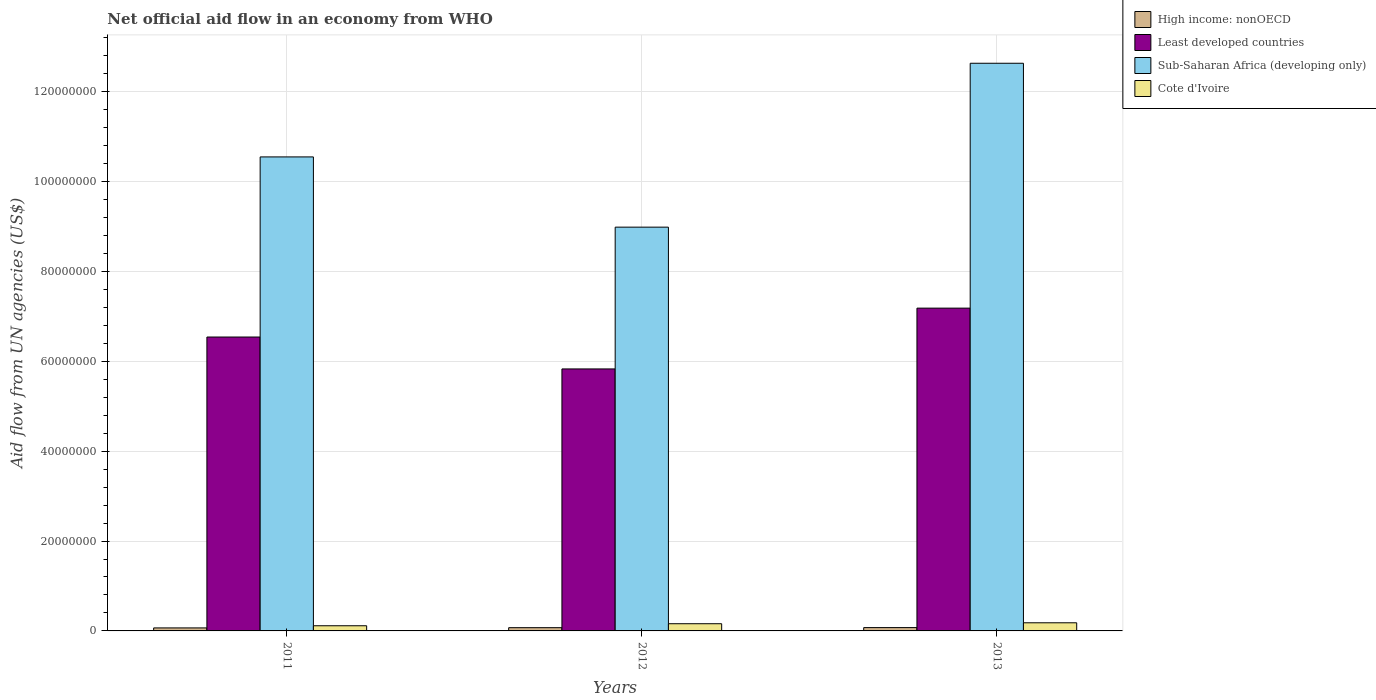How many groups of bars are there?
Offer a very short reply. 3. How many bars are there on the 2nd tick from the left?
Your response must be concise. 4. What is the label of the 1st group of bars from the left?
Provide a succinct answer. 2011. In how many cases, is the number of bars for a given year not equal to the number of legend labels?
Provide a short and direct response. 0. What is the net official aid flow in Sub-Saharan Africa (developing only) in 2011?
Your answer should be compact. 1.05e+08. Across all years, what is the maximum net official aid flow in Cote d'Ivoire?
Ensure brevity in your answer.  1.81e+06. Across all years, what is the minimum net official aid flow in High income: nonOECD?
Your answer should be compact. 6.70e+05. In which year was the net official aid flow in High income: nonOECD maximum?
Make the answer very short. 2013. What is the total net official aid flow in High income: nonOECD in the graph?
Make the answer very short. 2.13e+06. What is the difference between the net official aid flow in Sub-Saharan Africa (developing only) in 2011 and that in 2012?
Keep it short and to the point. 1.56e+07. What is the difference between the net official aid flow in Sub-Saharan Africa (developing only) in 2012 and the net official aid flow in Cote d'Ivoire in 2013?
Offer a terse response. 8.80e+07. What is the average net official aid flow in Least developed countries per year?
Offer a terse response. 6.52e+07. In the year 2011, what is the difference between the net official aid flow in Least developed countries and net official aid flow in Sub-Saharan Africa (developing only)?
Your response must be concise. -4.01e+07. In how many years, is the net official aid flow in Cote d'Ivoire greater than 76000000 US$?
Provide a short and direct response. 0. What is the ratio of the net official aid flow in High income: nonOECD in 2012 to that in 2013?
Give a very brief answer. 0.97. Is the difference between the net official aid flow in Least developed countries in 2012 and 2013 greater than the difference between the net official aid flow in Sub-Saharan Africa (developing only) in 2012 and 2013?
Offer a terse response. Yes. What is the difference between the highest and the second highest net official aid flow in Least developed countries?
Offer a very short reply. 6.43e+06. What is the difference between the highest and the lowest net official aid flow in High income: nonOECD?
Keep it short and to the point. 7.00e+04. In how many years, is the net official aid flow in Sub-Saharan Africa (developing only) greater than the average net official aid flow in Sub-Saharan Africa (developing only) taken over all years?
Your answer should be very brief. 1. What does the 3rd bar from the left in 2011 represents?
Provide a short and direct response. Sub-Saharan Africa (developing only). What does the 3rd bar from the right in 2011 represents?
Give a very brief answer. Least developed countries. Is it the case that in every year, the sum of the net official aid flow in Cote d'Ivoire and net official aid flow in Sub-Saharan Africa (developing only) is greater than the net official aid flow in Least developed countries?
Provide a short and direct response. Yes. Are the values on the major ticks of Y-axis written in scientific E-notation?
Your answer should be very brief. No. Does the graph contain grids?
Make the answer very short. Yes. Where does the legend appear in the graph?
Provide a short and direct response. Top right. How many legend labels are there?
Provide a short and direct response. 4. How are the legend labels stacked?
Your response must be concise. Vertical. What is the title of the graph?
Ensure brevity in your answer.  Net official aid flow in an economy from WHO. Does "Niger" appear as one of the legend labels in the graph?
Your response must be concise. No. What is the label or title of the Y-axis?
Your answer should be compact. Aid flow from UN agencies (US$). What is the Aid flow from UN agencies (US$) in High income: nonOECD in 2011?
Keep it short and to the point. 6.70e+05. What is the Aid flow from UN agencies (US$) of Least developed countries in 2011?
Offer a terse response. 6.54e+07. What is the Aid flow from UN agencies (US$) of Sub-Saharan Africa (developing only) in 2011?
Provide a short and direct response. 1.05e+08. What is the Aid flow from UN agencies (US$) in Cote d'Ivoire in 2011?
Keep it short and to the point. 1.15e+06. What is the Aid flow from UN agencies (US$) in High income: nonOECD in 2012?
Keep it short and to the point. 7.20e+05. What is the Aid flow from UN agencies (US$) in Least developed countries in 2012?
Make the answer very short. 5.83e+07. What is the Aid flow from UN agencies (US$) in Sub-Saharan Africa (developing only) in 2012?
Your response must be concise. 8.98e+07. What is the Aid flow from UN agencies (US$) of Cote d'Ivoire in 2012?
Provide a short and direct response. 1.60e+06. What is the Aid flow from UN agencies (US$) of High income: nonOECD in 2013?
Provide a succinct answer. 7.40e+05. What is the Aid flow from UN agencies (US$) of Least developed countries in 2013?
Provide a short and direct response. 7.18e+07. What is the Aid flow from UN agencies (US$) in Sub-Saharan Africa (developing only) in 2013?
Provide a succinct answer. 1.26e+08. What is the Aid flow from UN agencies (US$) in Cote d'Ivoire in 2013?
Offer a very short reply. 1.81e+06. Across all years, what is the maximum Aid flow from UN agencies (US$) of High income: nonOECD?
Offer a very short reply. 7.40e+05. Across all years, what is the maximum Aid flow from UN agencies (US$) in Least developed countries?
Keep it short and to the point. 7.18e+07. Across all years, what is the maximum Aid flow from UN agencies (US$) in Sub-Saharan Africa (developing only)?
Your answer should be compact. 1.26e+08. Across all years, what is the maximum Aid flow from UN agencies (US$) of Cote d'Ivoire?
Provide a short and direct response. 1.81e+06. Across all years, what is the minimum Aid flow from UN agencies (US$) in High income: nonOECD?
Make the answer very short. 6.70e+05. Across all years, what is the minimum Aid flow from UN agencies (US$) of Least developed countries?
Make the answer very short. 5.83e+07. Across all years, what is the minimum Aid flow from UN agencies (US$) in Sub-Saharan Africa (developing only)?
Make the answer very short. 8.98e+07. Across all years, what is the minimum Aid flow from UN agencies (US$) of Cote d'Ivoire?
Give a very brief answer. 1.15e+06. What is the total Aid flow from UN agencies (US$) in High income: nonOECD in the graph?
Your answer should be very brief. 2.13e+06. What is the total Aid flow from UN agencies (US$) of Least developed countries in the graph?
Make the answer very short. 1.96e+08. What is the total Aid flow from UN agencies (US$) of Sub-Saharan Africa (developing only) in the graph?
Your answer should be very brief. 3.22e+08. What is the total Aid flow from UN agencies (US$) of Cote d'Ivoire in the graph?
Ensure brevity in your answer.  4.56e+06. What is the difference between the Aid flow from UN agencies (US$) in High income: nonOECD in 2011 and that in 2012?
Your response must be concise. -5.00e+04. What is the difference between the Aid flow from UN agencies (US$) in Least developed countries in 2011 and that in 2012?
Your answer should be very brief. 7.10e+06. What is the difference between the Aid flow from UN agencies (US$) of Sub-Saharan Africa (developing only) in 2011 and that in 2012?
Provide a succinct answer. 1.56e+07. What is the difference between the Aid flow from UN agencies (US$) of Cote d'Ivoire in 2011 and that in 2012?
Offer a terse response. -4.50e+05. What is the difference between the Aid flow from UN agencies (US$) of Least developed countries in 2011 and that in 2013?
Your response must be concise. -6.43e+06. What is the difference between the Aid flow from UN agencies (US$) of Sub-Saharan Africa (developing only) in 2011 and that in 2013?
Ensure brevity in your answer.  -2.08e+07. What is the difference between the Aid flow from UN agencies (US$) in Cote d'Ivoire in 2011 and that in 2013?
Your answer should be very brief. -6.60e+05. What is the difference between the Aid flow from UN agencies (US$) in High income: nonOECD in 2012 and that in 2013?
Provide a succinct answer. -2.00e+04. What is the difference between the Aid flow from UN agencies (US$) of Least developed countries in 2012 and that in 2013?
Your answer should be compact. -1.35e+07. What is the difference between the Aid flow from UN agencies (US$) of Sub-Saharan Africa (developing only) in 2012 and that in 2013?
Offer a terse response. -3.65e+07. What is the difference between the Aid flow from UN agencies (US$) in Cote d'Ivoire in 2012 and that in 2013?
Your response must be concise. -2.10e+05. What is the difference between the Aid flow from UN agencies (US$) in High income: nonOECD in 2011 and the Aid flow from UN agencies (US$) in Least developed countries in 2012?
Provide a succinct answer. -5.76e+07. What is the difference between the Aid flow from UN agencies (US$) of High income: nonOECD in 2011 and the Aid flow from UN agencies (US$) of Sub-Saharan Africa (developing only) in 2012?
Make the answer very short. -8.92e+07. What is the difference between the Aid flow from UN agencies (US$) of High income: nonOECD in 2011 and the Aid flow from UN agencies (US$) of Cote d'Ivoire in 2012?
Your answer should be very brief. -9.30e+05. What is the difference between the Aid flow from UN agencies (US$) of Least developed countries in 2011 and the Aid flow from UN agencies (US$) of Sub-Saharan Africa (developing only) in 2012?
Your answer should be compact. -2.44e+07. What is the difference between the Aid flow from UN agencies (US$) in Least developed countries in 2011 and the Aid flow from UN agencies (US$) in Cote d'Ivoire in 2012?
Your answer should be compact. 6.38e+07. What is the difference between the Aid flow from UN agencies (US$) of Sub-Saharan Africa (developing only) in 2011 and the Aid flow from UN agencies (US$) of Cote d'Ivoire in 2012?
Ensure brevity in your answer.  1.04e+08. What is the difference between the Aid flow from UN agencies (US$) in High income: nonOECD in 2011 and the Aid flow from UN agencies (US$) in Least developed countries in 2013?
Make the answer very short. -7.12e+07. What is the difference between the Aid flow from UN agencies (US$) in High income: nonOECD in 2011 and the Aid flow from UN agencies (US$) in Sub-Saharan Africa (developing only) in 2013?
Offer a terse response. -1.26e+08. What is the difference between the Aid flow from UN agencies (US$) in High income: nonOECD in 2011 and the Aid flow from UN agencies (US$) in Cote d'Ivoire in 2013?
Give a very brief answer. -1.14e+06. What is the difference between the Aid flow from UN agencies (US$) of Least developed countries in 2011 and the Aid flow from UN agencies (US$) of Sub-Saharan Africa (developing only) in 2013?
Give a very brief answer. -6.09e+07. What is the difference between the Aid flow from UN agencies (US$) in Least developed countries in 2011 and the Aid flow from UN agencies (US$) in Cote d'Ivoire in 2013?
Your answer should be compact. 6.36e+07. What is the difference between the Aid flow from UN agencies (US$) of Sub-Saharan Africa (developing only) in 2011 and the Aid flow from UN agencies (US$) of Cote d'Ivoire in 2013?
Provide a succinct answer. 1.04e+08. What is the difference between the Aid flow from UN agencies (US$) of High income: nonOECD in 2012 and the Aid flow from UN agencies (US$) of Least developed countries in 2013?
Keep it short and to the point. -7.11e+07. What is the difference between the Aid flow from UN agencies (US$) of High income: nonOECD in 2012 and the Aid flow from UN agencies (US$) of Sub-Saharan Africa (developing only) in 2013?
Offer a terse response. -1.26e+08. What is the difference between the Aid flow from UN agencies (US$) in High income: nonOECD in 2012 and the Aid flow from UN agencies (US$) in Cote d'Ivoire in 2013?
Provide a short and direct response. -1.09e+06. What is the difference between the Aid flow from UN agencies (US$) of Least developed countries in 2012 and the Aid flow from UN agencies (US$) of Sub-Saharan Africa (developing only) in 2013?
Your answer should be compact. -6.80e+07. What is the difference between the Aid flow from UN agencies (US$) of Least developed countries in 2012 and the Aid flow from UN agencies (US$) of Cote d'Ivoire in 2013?
Your answer should be compact. 5.65e+07. What is the difference between the Aid flow from UN agencies (US$) of Sub-Saharan Africa (developing only) in 2012 and the Aid flow from UN agencies (US$) of Cote d'Ivoire in 2013?
Provide a short and direct response. 8.80e+07. What is the average Aid flow from UN agencies (US$) in High income: nonOECD per year?
Your response must be concise. 7.10e+05. What is the average Aid flow from UN agencies (US$) of Least developed countries per year?
Provide a short and direct response. 6.52e+07. What is the average Aid flow from UN agencies (US$) of Sub-Saharan Africa (developing only) per year?
Provide a short and direct response. 1.07e+08. What is the average Aid flow from UN agencies (US$) of Cote d'Ivoire per year?
Provide a short and direct response. 1.52e+06. In the year 2011, what is the difference between the Aid flow from UN agencies (US$) in High income: nonOECD and Aid flow from UN agencies (US$) in Least developed countries?
Offer a terse response. -6.47e+07. In the year 2011, what is the difference between the Aid flow from UN agencies (US$) of High income: nonOECD and Aid flow from UN agencies (US$) of Sub-Saharan Africa (developing only)?
Ensure brevity in your answer.  -1.05e+08. In the year 2011, what is the difference between the Aid flow from UN agencies (US$) of High income: nonOECD and Aid flow from UN agencies (US$) of Cote d'Ivoire?
Your answer should be compact. -4.80e+05. In the year 2011, what is the difference between the Aid flow from UN agencies (US$) of Least developed countries and Aid flow from UN agencies (US$) of Sub-Saharan Africa (developing only)?
Offer a terse response. -4.01e+07. In the year 2011, what is the difference between the Aid flow from UN agencies (US$) of Least developed countries and Aid flow from UN agencies (US$) of Cote d'Ivoire?
Provide a succinct answer. 6.42e+07. In the year 2011, what is the difference between the Aid flow from UN agencies (US$) in Sub-Saharan Africa (developing only) and Aid flow from UN agencies (US$) in Cote d'Ivoire?
Your answer should be very brief. 1.04e+08. In the year 2012, what is the difference between the Aid flow from UN agencies (US$) of High income: nonOECD and Aid flow from UN agencies (US$) of Least developed countries?
Make the answer very short. -5.76e+07. In the year 2012, what is the difference between the Aid flow from UN agencies (US$) of High income: nonOECD and Aid flow from UN agencies (US$) of Sub-Saharan Africa (developing only)?
Ensure brevity in your answer.  -8.91e+07. In the year 2012, what is the difference between the Aid flow from UN agencies (US$) in High income: nonOECD and Aid flow from UN agencies (US$) in Cote d'Ivoire?
Ensure brevity in your answer.  -8.80e+05. In the year 2012, what is the difference between the Aid flow from UN agencies (US$) of Least developed countries and Aid flow from UN agencies (US$) of Sub-Saharan Africa (developing only)?
Ensure brevity in your answer.  -3.16e+07. In the year 2012, what is the difference between the Aid flow from UN agencies (US$) in Least developed countries and Aid flow from UN agencies (US$) in Cote d'Ivoire?
Provide a succinct answer. 5.67e+07. In the year 2012, what is the difference between the Aid flow from UN agencies (US$) in Sub-Saharan Africa (developing only) and Aid flow from UN agencies (US$) in Cote d'Ivoire?
Make the answer very short. 8.82e+07. In the year 2013, what is the difference between the Aid flow from UN agencies (US$) in High income: nonOECD and Aid flow from UN agencies (US$) in Least developed countries?
Your answer should be compact. -7.11e+07. In the year 2013, what is the difference between the Aid flow from UN agencies (US$) in High income: nonOECD and Aid flow from UN agencies (US$) in Sub-Saharan Africa (developing only)?
Offer a very short reply. -1.26e+08. In the year 2013, what is the difference between the Aid flow from UN agencies (US$) of High income: nonOECD and Aid flow from UN agencies (US$) of Cote d'Ivoire?
Keep it short and to the point. -1.07e+06. In the year 2013, what is the difference between the Aid flow from UN agencies (US$) of Least developed countries and Aid flow from UN agencies (US$) of Sub-Saharan Africa (developing only)?
Offer a terse response. -5.45e+07. In the year 2013, what is the difference between the Aid flow from UN agencies (US$) in Least developed countries and Aid flow from UN agencies (US$) in Cote d'Ivoire?
Make the answer very short. 7.00e+07. In the year 2013, what is the difference between the Aid flow from UN agencies (US$) in Sub-Saharan Africa (developing only) and Aid flow from UN agencies (US$) in Cote d'Ivoire?
Offer a terse response. 1.25e+08. What is the ratio of the Aid flow from UN agencies (US$) in High income: nonOECD in 2011 to that in 2012?
Your answer should be compact. 0.93. What is the ratio of the Aid flow from UN agencies (US$) of Least developed countries in 2011 to that in 2012?
Your response must be concise. 1.12. What is the ratio of the Aid flow from UN agencies (US$) of Sub-Saharan Africa (developing only) in 2011 to that in 2012?
Give a very brief answer. 1.17. What is the ratio of the Aid flow from UN agencies (US$) of Cote d'Ivoire in 2011 to that in 2012?
Make the answer very short. 0.72. What is the ratio of the Aid flow from UN agencies (US$) in High income: nonOECD in 2011 to that in 2013?
Your response must be concise. 0.91. What is the ratio of the Aid flow from UN agencies (US$) in Least developed countries in 2011 to that in 2013?
Provide a short and direct response. 0.91. What is the ratio of the Aid flow from UN agencies (US$) of Sub-Saharan Africa (developing only) in 2011 to that in 2013?
Provide a short and direct response. 0.83. What is the ratio of the Aid flow from UN agencies (US$) of Cote d'Ivoire in 2011 to that in 2013?
Give a very brief answer. 0.64. What is the ratio of the Aid flow from UN agencies (US$) in Least developed countries in 2012 to that in 2013?
Provide a succinct answer. 0.81. What is the ratio of the Aid flow from UN agencies (US$) of Sub-Saharan Africa (developing only) in 2012 to that in 2013?
Keep it short and to the point. 0.71. What is the ratio of the Aid flow from UN agencies (US$) in Cote d'Ivoire in 2012 to that in 2013?
Provide a succinct answer. 0.88. What is the difference between the highest and the second highest Aid flow from UN agencies (US$) of Least developed countries?
Offer a terse response. 6.43e+06. What is the difference between the highest and the second highest Aid flow from UN agencies (US$) of Sub-Saharan Africa (developing only)?
Your response must be concise. 2.08e+07. What is the difference between the highest and the lowest Aid flow from UN agencies (US$) of High income: nonOECD?
Ensure brevity in your answer.  7.00e+04. What is the difference between the highest and the lowest Aid flow from UN agencies (US$) of Least developed countries?
Offer a very short reply. 1.35e+07. What is the difference between the highest and the lowest Aid flow from UN agencies (US$) in Sub-Saharan Africa (developing only)?
Make the answer very short. 3.65e+07. What is the difference between the highest and the lowest Aid flow from UN agencies (US$) in Cote d'Ivoire?
Your answer should be very brief. 6.60e+05. 